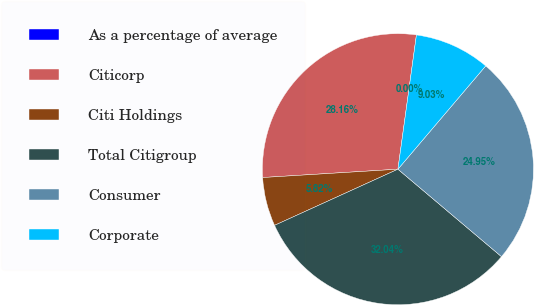<chart> <loc_0><loc_0><loc_500><loc_500><pie_chart><fcel>As a percentage of average<fcel>Citicorp<fcel>Citi Holdings<fcel>Total Citigroup<fcel>Consumer<fcel>Corporate<nl><fcel>0.0%<fcel>28.16%<fcel>5.82%<fcel>32.04%<fcel>24.95%<fcel>9.03%<nl></chart> 